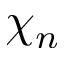<formula> <loc_0><loc_0><loc_500><loc_500>\chi _ { n }</formula> 